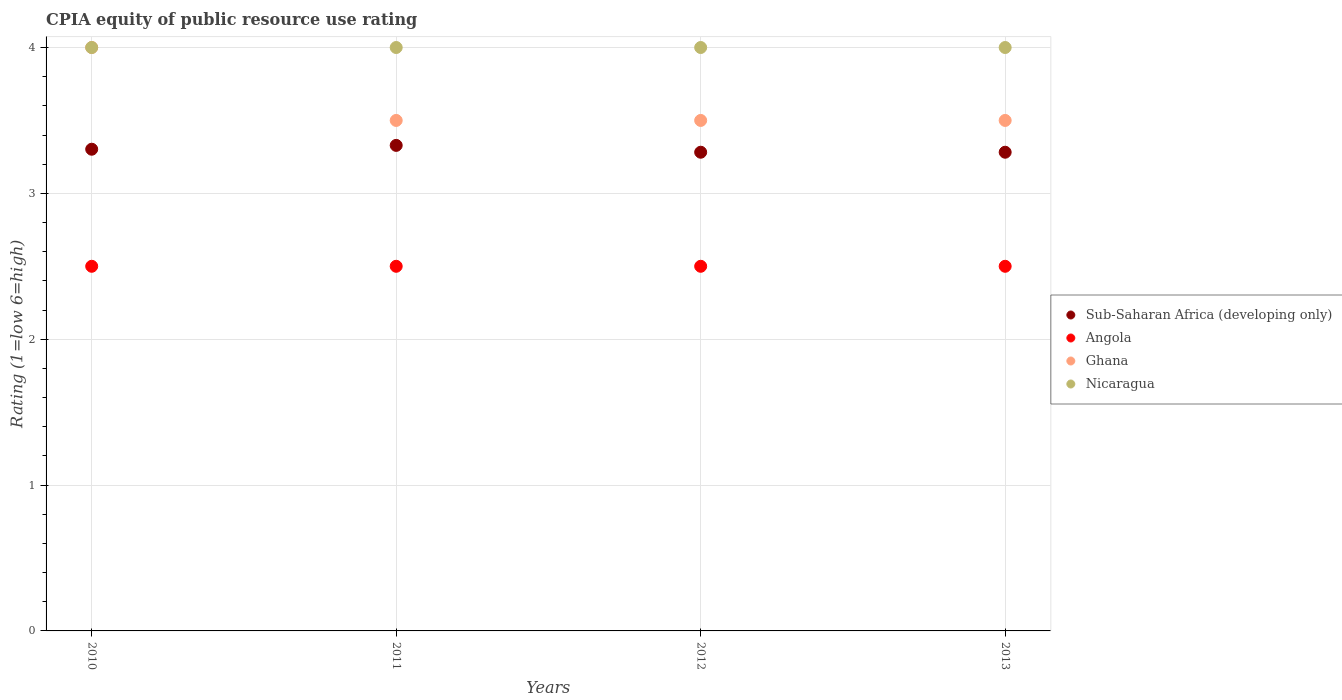Is the number of dotlines equal to the number of legend labels?
Offer a very short reply. Yes. What is the CPIA rating in Sub-Saharan Africa (developing only) in 2013?
Provide a short and direct response. 3.28. Across all years, what is the maximum CPIA rating in Sub-Saharan Africa (developing only)?
Provide a succinct answer. 3.33. In which year was the CPIA rating in Nicaragua maximum?
Provide a short and direct response. 2010. In which year was the CPIA rating in Sub-Saharan Africa (developing only) minimum?
Make the answer very short. 2012. What is the total CPIA rating in Sub-Saharan Africa (developing only) in the graph?
Provide a short and direct response. 13.2. What is the difference between the CPIA rating in Sub-Saharan Africa (developing only) in 2010 and that in 2012?
Your answer should be very brief. 0.02. What is the average CPIA rating in Sub-Saharan Africa (developing only) per year?
Keep it short and to the point. 3.3. In the year 2012, what is the difference between the CPIA rating in Sub-Saharan Africa (developing only) and CPIA rating in Ghana?
Give a very brief answer. -0.22. What is the ratio of the CPIA rating in Angola in 2010 to that in 2012?
Ensure brevity in your answer.  1. Is the CPIA rating in Sub-Saharan Africa (developing only) in 2010 less than that in 2011?
Provide a short and direct response. Yes. What is the difference between the highest and the lowest CPIA rating in Sub-Saharan Africa (developing only)?
Ensure brevity in your answer.  0.05. Is the sum of the CPIA rating in Ghana in 2012 and 2013 greater than the maximum CPIA rating in Nicaragua across all years?
Provide a short and direct response. Yes. Is it the case that in every year, the sum of the CPIA rating in Ghana and CPIA rating in Nicaragua  is greater than the CPIA rating in Angola?
Ensure brevity in your answer.  Yes. How many dotlines are there?
Keep it short and to the point. 4. Are the values on the major ticks of Y-axis written in scientific E-notation?
Your answer should be compact. No. Does the graph contain any zero values?
Make the answer very short. No. Does the graph contain grids?
Your answer should be very brief. Yes. Where does the legend appear in the graph?
Make the answer very short. Center right. How many legend labels are there?
Ensure brevity in your answer.  4. How are the legend labels stacked?
Give a very brief answer. Vertical. What is the title of the graph?
Ensure brevity in your answer.  CPIA equity of public resource use rating. Does "Gambia, The" appear as one of the legend labels in the graph?
Give a very brief answer. No. What is the Rating (1=low 6=high) of Sub-Saharan Africa (developing only) in 2010?
Ensure brevity in your answer.  3.3. What is the Rating (1=low 6=high) in Angola in 2010?
Offer a terse response. 2.5. What is the Rating (1=low 6=high) of Nicaragua in 2010?
Give a very brief answer. 4. What is the Rating (1=low 6=high) of Sub-Saharan Africa (developing only) in 2011?
Your answer should be compact. 3.33. What is the Rating (1=low 6=high) in Angola in 2011?
Make the answer very short. 2.5. What is the Rating (1=low 6=high) in Ghana in 2011?
Keep it short and to the point. 3.5. What is the Rating (1=low 6=high) in Nicaragua in 2011?
Keep it short and to the point. 4. What is the Rating (1=low 6=high) in Sub-Saharan Africa (developing only) in 2012?
Ensure brevity in your answer.  3.28. What is the Rating (1=low 6=high) of Angola in 2012?
Keep it short and to the point. 2.5. What is the Rating (1=low 6=high) of Ghana in 2012?
Your answer should be compact. 3.5. What is the Rating (1=low 6=high) of Nicaragua in 2012?
Provide a short and direct response. 4. What is the Rating (1=low 6=high) of Sub-Saharan Africa (developing only) in 2013?
Your answer should be very brief. 3.28. What is the Rating (1=low 6=high) of Angola in 2013?
Your answer should be very brief. 2.5. What is the Rating (1=low 6=high) of Ghana in 2013?
Your answer should be compact. 3.5. What is the Rating (1=low 6=high) in Nicaragua in 2013?
Make the answer very short. 4. Across all years, what is the maximum Rating (1=low 6=high) of Sub-Saharan Africa (developing only)?
Offer a very short reply. 3.33. Across all years, what is the maximum Rating (1=low 6=high) of Angola?
Provide a succinct answer. 2.5. Across all years, what is the minimum Rating (1=low 6=high) of Sub-Saharan Africa (developing only)?
Provide a short and direct response. 3.28. Across all years, what is the minimum Rating (1=low 6=high) of Angola?
Give a very brief answer. 2.5. Across all years, what is the minimum Rating (1=low 6=high) in Ghana?
Offer a terse response. 3.5. What is the total Rating (1=low 6=high) of Sub-Saharan Africa (developing only) in the graph?
Offer a terse response. 13.2. What is the total Rating (1=low 6=high) in Ghana in the graph?
Your response must be concise. 14.5. What is the difference between the Rating (1=low 6=high) in Sub-Saharan Africa (developing only) in 2010 and that in 2011?
Your answer should be very brief. -0.03. What is the difference between the Rating (1=low 6=high) of Ghana in 2010 and that in 2011?
Make the answer very short. 0.5. What is the difference between the Rating (1=low 6=high) of Nicaragua in 2010 and that in 2011?
Give a very brief answer. 0. What is the difference between the Rating (1=low 6=high) of Sub-Saharan Africa (developing only) in 2010 and that in 2012?
Ensure brevity in your answer.  0.02. What is the difference between the Rating (1=low 6=high) in Angola in 2010 and that in 2012?
Ensure brevity in your answer.  0. What is the difference between the Rating (1=low 6=high) in Sub-Saharan Africa (developing only) in 2010 and that in 2013?
Make the answer very short. 0.02. What is the difference between the Rating (1=low 6=high) of Ghana in 2010 and that in 2013?
Your answer should be very brief. 0.5. What is the difference between the Rating (1=low 6=high) in Sub-Saharan Africa (developing only) in 2011 and that in 2012?
Offer a terse response. 0.05. What is the difference between the Rating (1=low 6=high) in Angola in 2011 and that in 2012?
Make the answer very short. 0. What is the difference between the Rating (1=low 6=high) in Sub-Saharan Africa (developing only) in 2011 and that in 2013?
Make the answer very short. 0.05. What is the difference between the Rating (1=low 6=high) of Angola in 2011 and that in 2013?
Offer a terse response. 0. What is the difference between the Rating (1=low 6=high) in Ghana in 2012 and that in 2013?
Give a very brief answer. 0. What is the difference between the Rating (1=low 6=high) of Sub-Saharan Africa (developing only) in 2010 and the Rating (1=low 6=high) of Angola in 2011?
Your answer should be very brief. 0.8. What is the difference between the Rating (1=low 6=high) in Sub-Saharan Africa (developing only) in 2010 and the Rating (1=low 6=high) in Ghana in 2011?
Offer a very short reply. -0.2. What is the difference between the Rating (1=low 6=high) of Sub-Saharan Africa (developing only) in 2010 and the Rating (1=low 6=high) of Nicaragua in 2011?
Your answer should be very brief. -0.7. What is the difference between the Rating (1=low 6=high) of Sub-Saharan Africa (developing only) in 2010 and the Rating (1=low 6=high) of Angola in 2012?
Your answer should be very brief. 0.8. What is the difference between the Rating (1=low 6=high) in Sub-Saharan Africa (developing only) in 2010 and the Rating (1=low 6=high) in Ghana in 2012?
Provide a short and direct response. -0.2. What is the difference between the Rating (1=low 6=high) of Sub-Saharan Africa (developing only) in 2010 and the Rating (1=low 6=high) of Nicaragua in 2012?
Your response must be concise. -0.7. What is the difference between the Rating (1=low 6=high) in Angola in 2010 and the Rating (1=low 6=high) in Ghana in 2012?
Keep it short and to the point. -1. What is the difference between the Rating (1=low 6=high) of Ghana in 2010 and the Rating (1=low 6=high) of Nicaragua in 2012?
Offer a terse response. 0. What is the difference between the Rating (1=low 6=high) in Sub-Saharan Africa (developing only) in 2010 and the Rating (1=low 6=high) in Angola in 2013?
Keep it short and to the point. 0.8. What is the difference between the Rating (1=low 6=high) of Sub-Saharan Africa (developing only) in 2010 and the Rating (1=low 6=high) of Ghana in 2013?
Offer a terse response. -0.2. What is the difference between the Rating (1=low 6=high) in Sub-Saharan Africa (developing only) in 2010 and the Rating (1=low 6=high) in Nicaragua in 2013?
Your answer should be very brief. -0.7. What is the difference between the Rating (1=low 6=high) of Angola in 2010 and the Rating (1=low 6=high) of Nicaragua in 2013?
Give a very brief answer. -1.5. What is the difference between the Rating (1=low 6=high) in Sub-Saharan Africa (developing only) in 2011 and the Rating (1=low 6=high) in Angola in 2012?
Provide a succinct answer. 0.83. What is the difference between the Rating (1=low 6=high) in Sub-Saharan Africa (developing only) in 2011 and the Rating (1=low 6=high) in Ghana in 2012?
Your response must be concise. -0.17. What is the difference between the Rating (1=low 6=high) in Sub-Saharan Africa (developing only) in 2011 and the Rating (1=low 6=high) in Nicaragua in 2012?
Offer a terse response. -0.67. What is the difference between the Rating (1=low 6=high) of Sub-Saharan Africa (developing only) in 2011 and the Rating (1=low 6=high) of Angola in 2013?
Your answer should be very brief. 0.83. What is the difference between the Rating (1=low 6=high) of Sub-Saharan Africa (developing only) in 2011 and the Rating (1=low 6=high) of Ghana in 2013?
Provide a succinct answer. -0.17. What is the difference between the Rating (1=low 6=high) in Sub-Saharan Africa (developing only) in 2011 and the Rating (1=low 6=high) in Nicaragua in 2013?
Ensure brevity in your answer.  -0.67. What is the difference between the Rating (1=low 6=high) in Angola in 2011 and the Rating (1=low 6=high) in Nicaragua in 2013?
Offer a terse response. -1.5. What is the difference between the Rating (1=low 6=high) in Sub-Saharan Africa (developing only) in 2012 and the Rating (1=low 6=high) in Angola in 2013?
Your answer should be compact. 0.78. What is the difference between the Rating (1=low 6=high) in Sub-Saharan Africa (developing only) in 2012 and the Rating (1=low 6=high) in Ghana in 2013?
Make the answer very short. -0.22. What is the difference between the Rating (1=low 6=high) of Sub-Saharan Africa (developing only) in 2012 and the Rating (1=low 6=high) of Nicaragua in 2013?
Give a very brief answer. -0.72. What is the difference between the Rating (1=low 6=high) of Angola in 2012 and the Rating (1=low 6=high) of Nicaragua in 2013?
Make the answer very short. -1.5. What is the average Rating (1=low 6=high) in Sub-Saharan Africa (developing only) per year?
Keep it short and to the point. 3.3. What is the average Rating (1=low 6=high) of Ghana per year?
Make the answer very short. 3.62. In the year 2010, what is the difference between the Rating (1=low 6=high) in Sub-Saharan Africa (developing only) and Rating (1=low 6=high) in Angola?
Provide a succinct answer. 0.8. In the year 2010, what is the difference between the Rating (1=low 6=high) in Sub-Saharan Africa (developing only) and Rating (1=low 6=high) in Ghana?
Provide a succinct answer. -0.7. In the year 2010, what is the difference between the Rating (1=low 6=high) of Sub-Saharan Africa (developing only) and Rating (1=low 6=high) of Nicaragua?
Provide a succinct answer. -0.7. In the year 2010, what is the difference between the Rating (1=low 6=high) in Ghana and Rating (1=low 6=high) in Nicaragua?
Offer a terse response. 0. In the year 2011, what is the difference between the Rating (1=low 6=high) of Sub-Saharan Africa (developing only) and Rating (1=low 6=high) of Angola?
Your answer should be very brief. 0.83. In the year 2011, what is the difference between the Rating (1=low 6=high) in Sub-Saharan Africa (developing only) and Rating (1=low 6=high) in Ghana?
Provide a short and direct response. -0.17. In the year 2011, what is the difference between the Rating (1=low 6=high) of Sub-Saharan Africa (developing only) and Rating (1=low 6=high) of Nicaragua?
Ensure brevity in your answer.  -0.67. In the year 2012, what is the difference between the Rating (1=low 6=high) of Sub-Saharan Africa (developing only) and Rating (1=low 6=high) of Angola?
Make the answer very short. 0.78. In the year 2012, what is the difference between the Rating (1=low 6=high) in Sub-Saharan Africa (developing only) and Rating (1=low 6=high) in Ghana?
Keep it short and to the point. -0.22. In the year 2012, what is the difference between the Rating (1=low 6=high) in Sub-Saharan Africa (developing only) and Rating (1=low 6=high) in Nicaragua?
Make the answer very short. -0.72. In the year 2012, what is the difference between the Rating (1=low 6=high) of Angola and Rating (1=low 6=high) of Ghana?
Your response must be concise. -1. In the year 2012, what is the difference between the Rating (1=low 6=high) in Angola and Rating (1=low 6=high) in Nicaragua?
Provide a succinct answer. -1.5. In the year 2013, what is the difference between the Rating (1=low 6=high) of Sub-Saharan Africa (developing only) and Rating (1=low 6=high) of Angola?
Offer a terse response. 0.78. In the year 2013, what is the difference between the Rating (1=low 6=high) in Sub-Saharan Africa (developing only) and Rating (1=low 6=high) in Ghana?
Offer a terse response. -0.22. In the year 2013, what is the difference between the Rating (1=low 6=high) of Sub-Saharan Africa (developing only) and Rating (1=low 6=high) of Nicaragua?
Give a very brief answer. -0.72. In the year 2013, what is the difference between the Rating (1=low 6=high) of Angola and Rating (1=low 6=high) of Ghana?
Provide a succinct answer. -1. In the year 2013, what is the difference between the Rating (1=low 6=high) in Angola and Rating (1=low 6=high) in Nicaragua?
Keep it short and to the point. -1.5. What is the ratio of the Rating (1=low 6=high) in Sub-Saharan Africa (developing only) in 2010 to that in 2011?
Offer a very short reply. 0.99. What is the ratio of the Rating (1=low 6=high) of Angola in 2010 to that in 2011?
Your answer should be very brief. 1. What is the ratio of the Rating (1=low 6=high) in Nicaragua in 2010 to that in 2012?
Provide a short and direct response. 1. What is the ratio of the Rating (1=low 6=high) of Sub-Saharan Africa (developing only) in 2010 to that in 2013?
Give a very brief answer. 1.01. What is the ratio of the Rating (1=low 6=high) of Nicaragua in 2010 to that in 2013?
Offer a terse response. 1. What is the ratio of the Rating (1=low 6=high) of Sub-Saharan Africa (developing only) in 2011 to that in 2012?
Your response must be concise. 1.01. What is the ratio of the Rating (1=low 6=high) in Ghana in 2011 to that in 2012?
Keep it short and to the point. 1. What is the ratio of the Rating (1=low 6=high) in Nicaragua in 2011 to that in 2012?
Make the answer very short. 1. What is the ratio of the Rating (1=low 6=high) in Sub-Saharan Africa (developing only) in 2011 to that in 2013?
Provide a succinct answer. 1.01. What is the ratio of the Rating (1=low 6=high) of Ghana in 2011 to that in 2013?
Make the answer very short. 1. What is the ratio of the Rating (1=low 6=high) in Angola in 2012 to that in 2013?
Your response must be concise. 1. What is the ratio of the Rating (1=low 6=high) of Ghana in 2012 to that in 2013?
Your response must be concise. 1. What is the difference between the highest and the second highest Rating (1=low 6=high) in Sub-Saharan Africa (developing only)?
Keep it short and to the point. 0.03. What is the difference between the highest and the second highest Rating (1=low 6=high) in Nicaragua?
Offer a terse response. 0. What is the difference between the highest and the lowest Rating (1=low 6=high) in Sub-Saharan Africa (developing only)?
Provide a short and direct response. 0.05. 